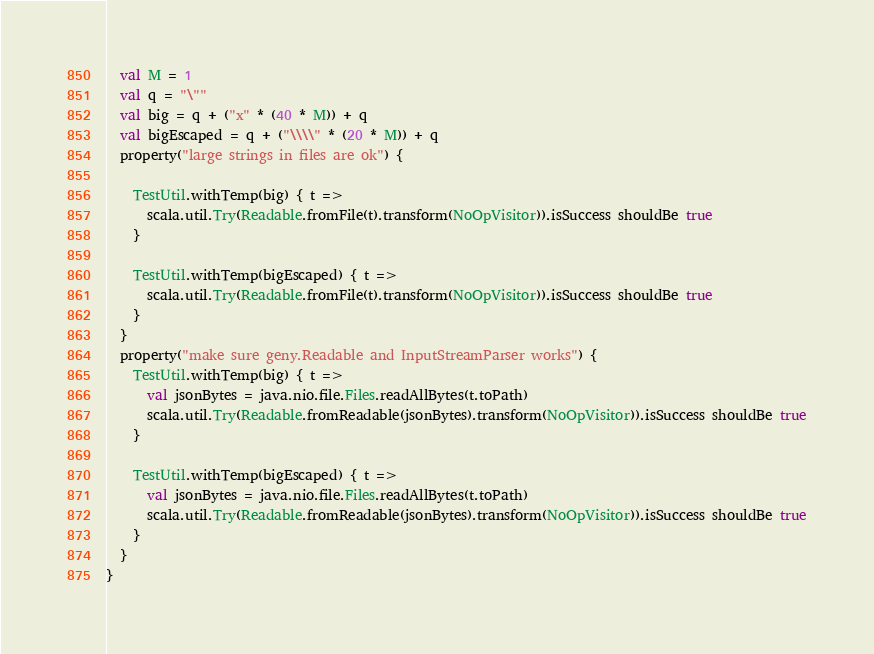<code> <loc_0><loc_0><loc_500><loc_500><_Scala_>  val M = 1
  val q = "\""
  val big = q + ("x" * (40 * M)) + q
  val bigEscaped = q + ("\\\\" * (20 * M)) + q
  property("large strings in files are ok") {

    TestUtil.withTemp(big) { t =>
      scala.util.Try(Readable.fromFile(t).transform(NoOpVisitor)).isSuccess shouldBe true
    }

    TestUtil.withTemp(bigEscaped) { t =>
      scala.util.Try(Readable.fromFile(t).transform(NoOpVisitor)).isSuccess shouldBe true
    }
  }
  property("make sure geny.Readable and InputStreamParser works") {
    TestUtil.withTemp(big) { t =>
      val jsonBytes = java.nio.file.Files.readAllBytes(t.toPath)
      scala.util.Try(Readable.fromReadable(jsonBytes).transform(NoOpVisitor)).isSuccess shouldBe true
    }

    TestUtil.withTemp(bigEscaped) { t =>
      val jsonBytes = java.nio.file.Files.readAllBytes(t.toPath)
      scala.util.Try(Readable.fromReadable(jsonBytes).transform(NoOpVisitor)).isSuccess shouldBe true
    }
  }
}
</code> 